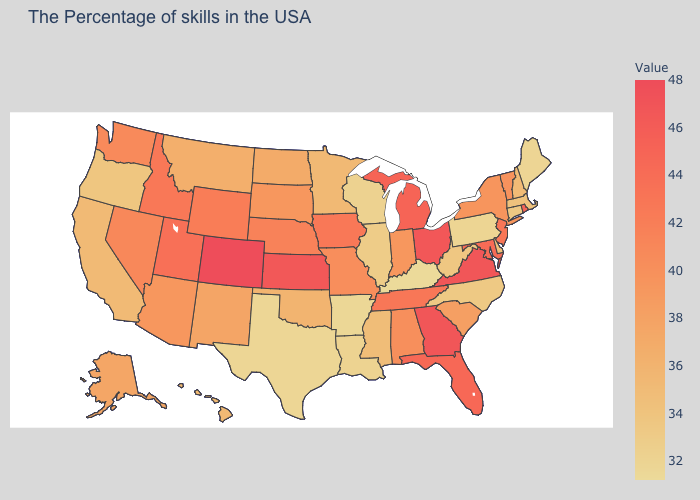Among the states that border New Mexico , does Texas have the highest value?
Short answer required. No. Which states have the lowest value in the USA?
Answer briefly. Kentucky. Does the map have missing data?
Write a very short answer. No. Among the states that border Nebraska , which have the lowest value?
Quick response, please. South Dakota. 